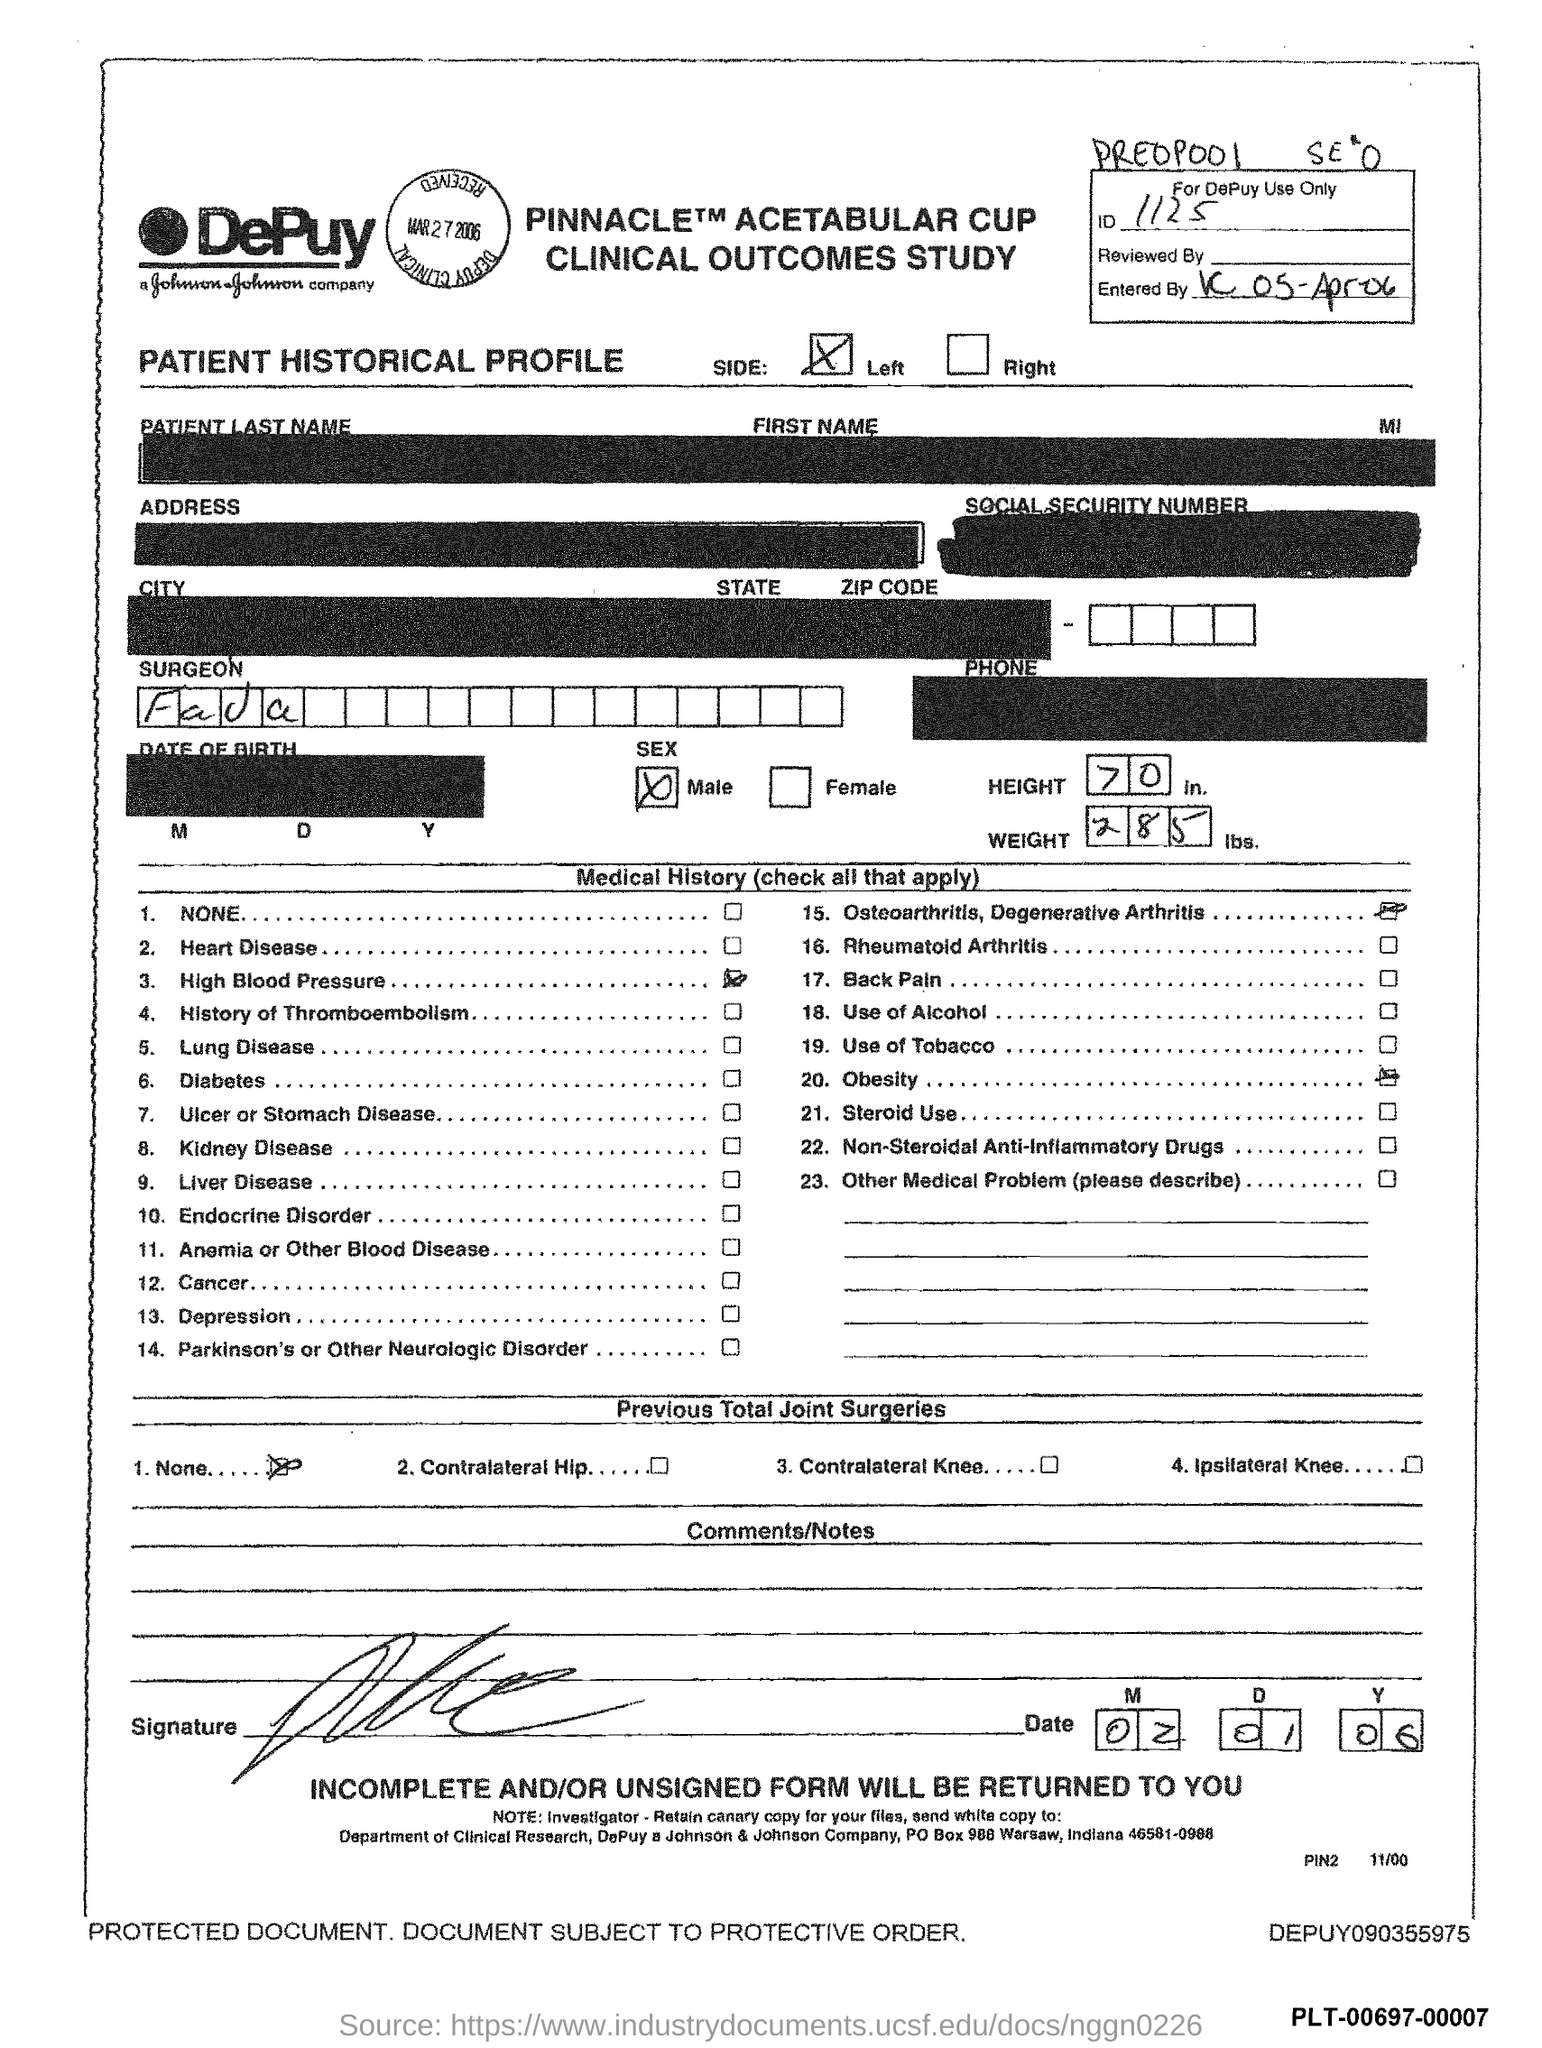Point out several critical features in this image. The height is 70 inches. The date is February 1, 2006. The question "What is the ID?" is a request for information, possibly about an identification number or document. The answer given, "1125...", could be the ID number or code in question. The sentence could be rephrased as: "What is the ID number or code? 1125...". 